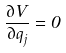Convert formula to latex. <formula><loc_0><loc_0><loc_500><loc_500>\frac { \partial V } { \partial q _ { j } } = 0</formula> 